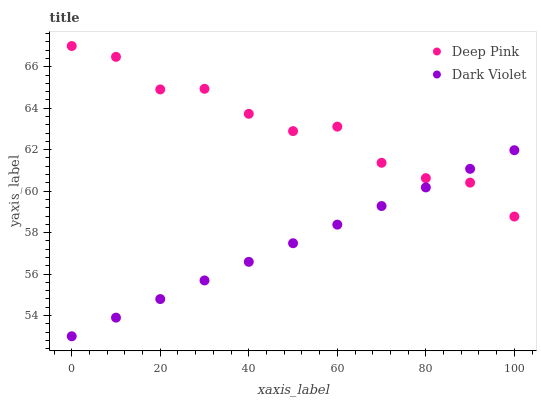Does Dark Violet have the minimum area under the curve?
Answer yes or no. Yes. Does Deep Pink have the maximum area under the curve?
Answer yes or no. Yes. Does Dark Violet have the maximum area under the curve?
Answer yes or no. No. Is Dark Violet the smoothest?
Answer yes or no. Yes. Is Deep Pink the roughest?
Answer yes or no. Yes. Is Dark Violet the roughest?
Answer yes or no. No. Does Dark Violet have the lowest value?
Answer yes or no. Yes. Does Deep Pink have the highest value?
Answer yes or no. Yes. Does Dark Violet have the highest value?
Answer yes or no. No. Does Dark Violet intersect Deep Pink?
Answer yes or no. Yes. Is Dark Violet less than Deep Pink?
Answer yes or no. No. Is Dark Violet greater than Deep Pink?
Answer yes or no. No. 